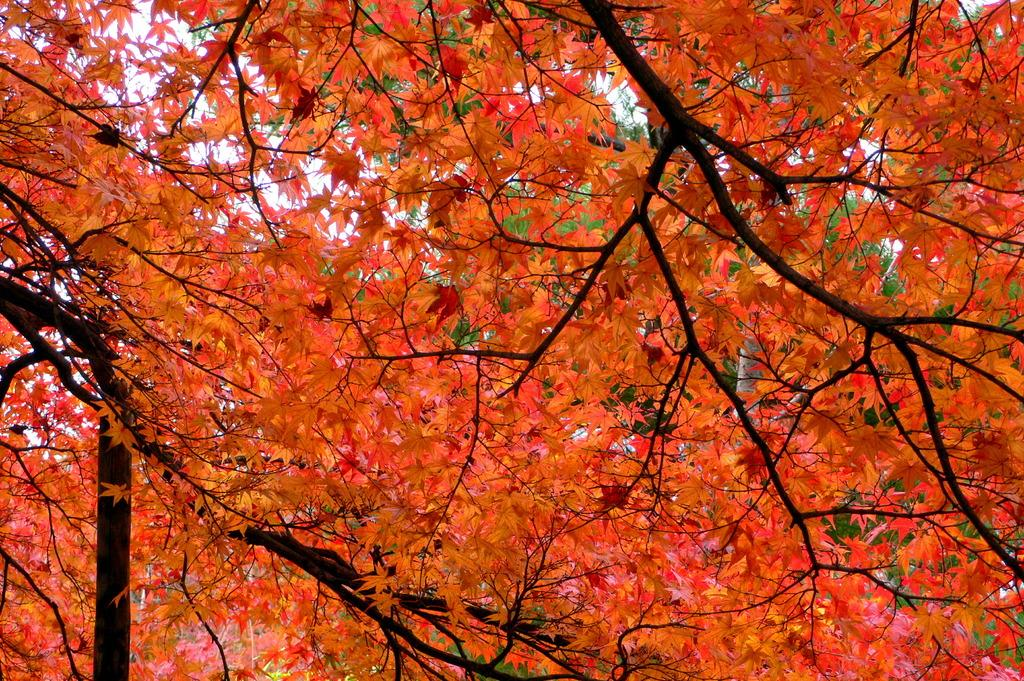What is the main subject of the image? There is a tree in the image. What colors are the tree's leaves? The tree's leaves are in red and orange colors. What other colors of leaves can be seen in the image? There are green color leaves visible in the background. What else can be seen in the image besides the tree and leaves? The sky is visible in the image. Can you tell me how many birds are sitting on the tree in the image? There are no birds visible in the image; it only features a tree with leaves in red, orange, and green colors, and a visible sky. 